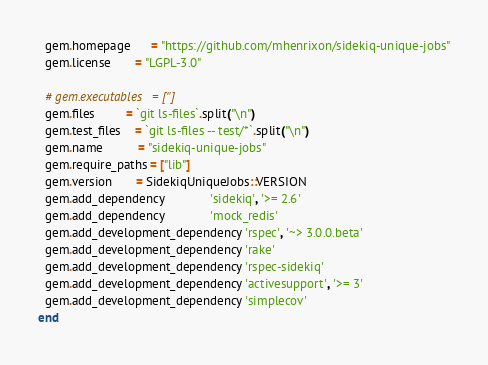Convert code to text. <code><loc_0><loc_0><loc_500><loc_500><_Ruby_>  gem.homepage      = "https://github.com/mhenrixon/sidekiq-unique-jobs"
  gem.license       = "LGPL-3.0"

  # gem.executables   = ['']
  gem.files         = `git ls-files`.split("\n")
  gem.test_files    = `git ls-files -- test/*`.split("\n")
  gem.name          = "sidekiq-unique-jobs"
  gem.require_paths = ["lib"]
  gem.version       = SidekiqUniqueJobs::VERSION
  gem.add_dependency             'sidekiq', '>= 2.6'
  gem.add_dependency             'mock_redis'
  gem.add_development_dependency 'rspec', '~> 3.0.0.beta'
  gem.add_development_dependency 'rake'
  gem.add_development_dependency 'rspec-sidekiq'
  gem.add_development_dependency 'activesupport', '>= 3'
  gem.add_development_dependency 'simplecov'
end
</code> 